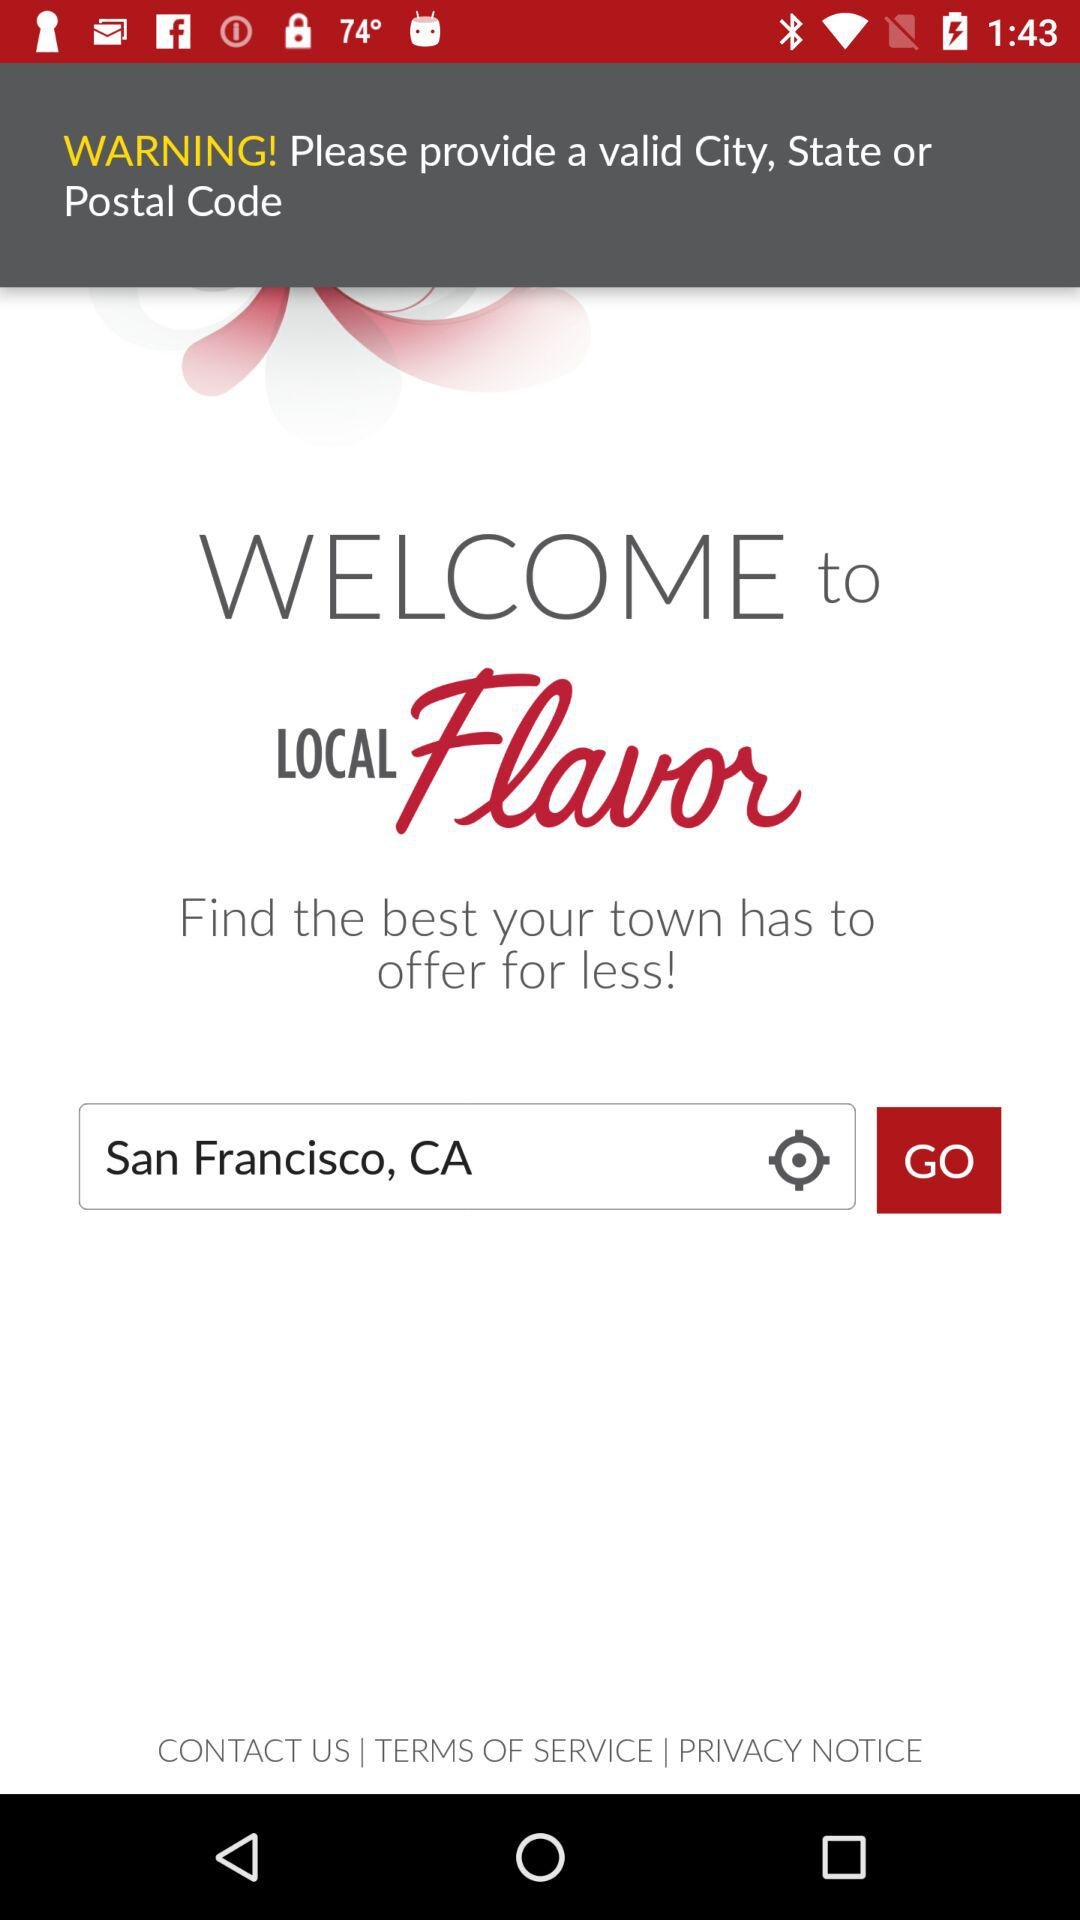What message is displayed as a warning? The message displayed as a warning is "Please provide a valid City, State or Postal Code". 